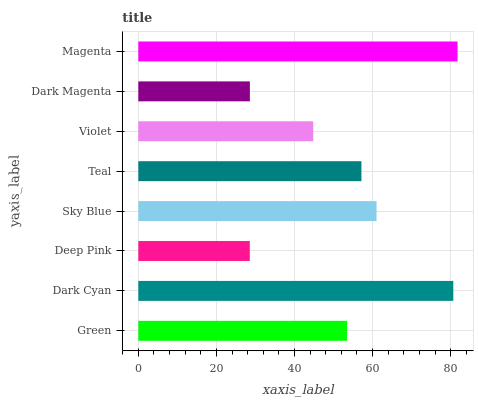Is Deep Pink the minimum?
Answer yes or no. Yes. Is Magenta the maximum?
Answer yes or no. Yes. Is Dark Cyan the minimum?
Answer yes or no. No. Is Dark Cyan the maximum?
Answer yes or no. No. Is Dark Cyan greater than Green?
Answer yes or no. Yes. Is Green less than Dark Cyan?
Answer yes or no. Yes. Is Green greater than Dark Cyan?
Answer yes or no. No. Is Dark Cyan less than Green?
Answer yes or no. No. Is Teal the high median?
Answer yes or no. Yes. Is Green the low median?
Answer yes or no. Yes. Is Sky Blue the high median?
Answer yes or no. No. Is Violet the low median?
Answer yes or no. No. 